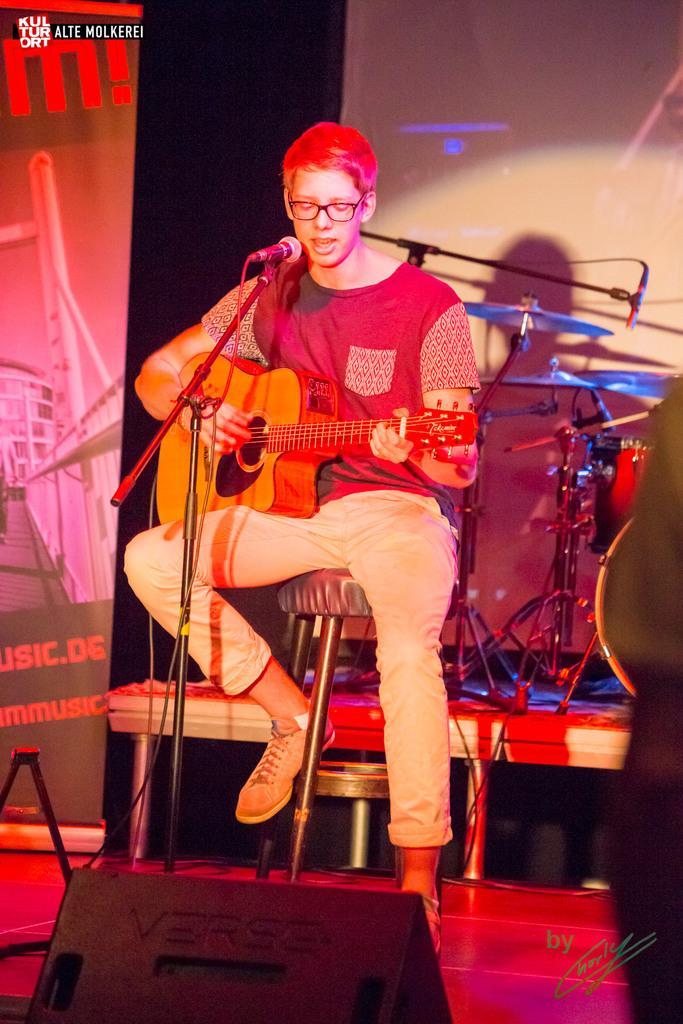Can you describe this image briefly? A man is sitting on the stool playing the guitar and also singing. 